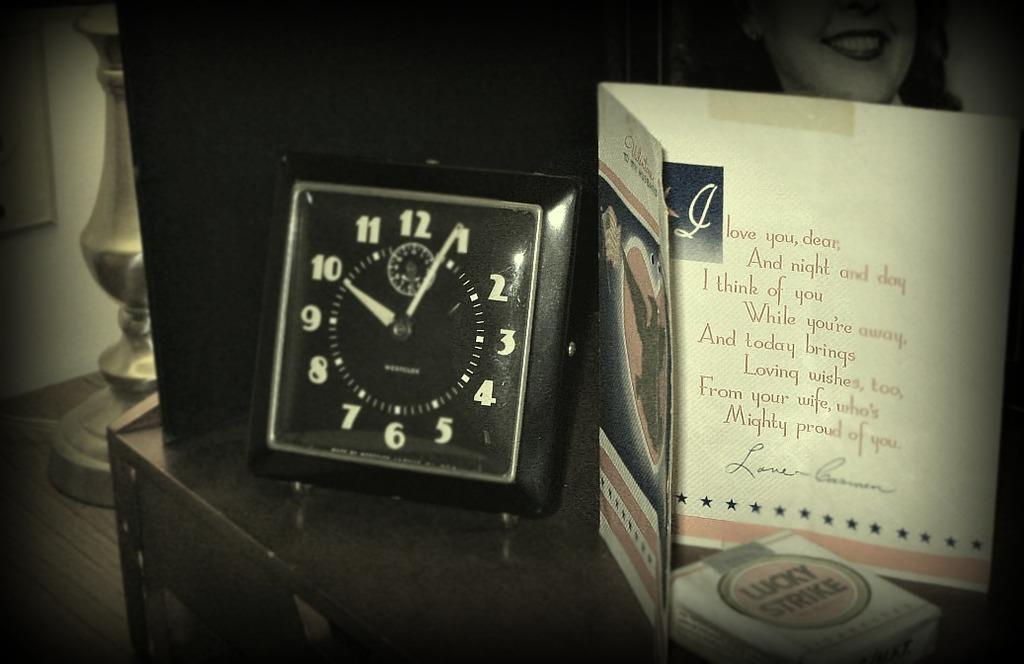What are the cigarettes with no filter next to the card?
Your answer should be very brief. Lucky strike. According to the card, what does today bring?
Offer a terse response. Loving wishes. 